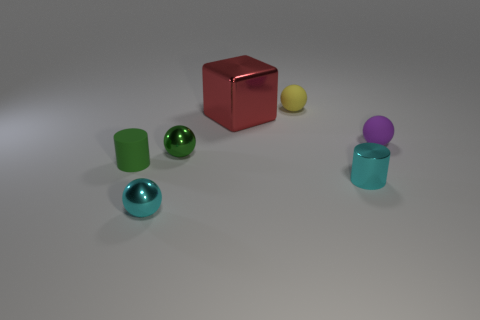Add 2 tiny purple rubber objects. How many objects exist? 9 Subtract all cubes. How many objects are left? 6 Add 3 small spheres. How many small spheres exist? 7 Subtract 0 blue cylinders. How many objects are left? 7 Subtract all big metal things. Subtract all purple matte things. How many objects are left? 5 Add 4 large red things. How many large red things are left? 5 